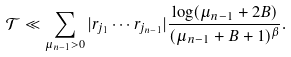<formula> <loc_0><loc_0><loc_500><loc_500>\mathcal { T } \ll \sum _ { \mu _ { n - 1 } > 0 } | r _ { j _ { 1 } } \cdots r _ { j _ { n - 1 } } | \frac { \log ( \mu _ { n - 1 } + 2 B ) } { ( \mu _ { n - 1 } + B + 1 ) ^ { \beta } } .</formula> 